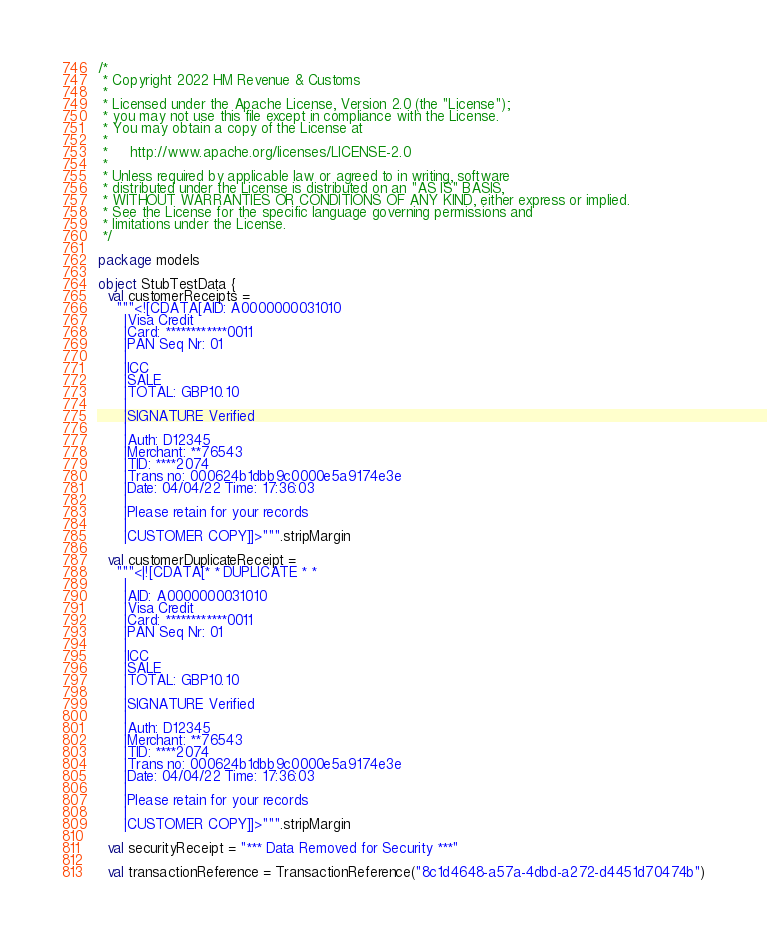<code> <loc_0><loc_0><loc_500><loc_500><_Scala_>/*
 * Copyright 2022 HM Revenue & Customs
 *
 * Licensed under the Apache License, Version 2.0 (the "License");
 * you may not use this file except in compliance with the License.
 * You may obtain a copy of the License at
 *
 *     http://www.apache.org/licenses/LICENSE-2.0
 *
 * Unless required by applicable law or agreed to in writing, software
 * distributed under the License is distributed on an "AS IS" BASIS,
 * WITHOUT WARRANTIES OR CONDITIONS OF ANY KIND, either express or implied.
 * See the License for the specific language governing permissions and
 * limitations under the License.
 */

package models

object StubTestData {
  val customerReceipts =
    """<![CDATA[AID: A0000000031010
      |Visa Credit
      |Card: ************0011
      |PAN Seq Nr: 01
      |
      |ICC
      |SALE
      |TOTAL: GBP10.10
      |
      |SIGNATURE Verified
      |
      |Auth: D12345
      |Merchant: **76543
      |TID: ****2074
      |Trans no: 000624b1dbb9c0000e5a9174e3e
      |Date: 04/04/22 Time: 17:36:03
      |
      |Please retain for your records
      |
      |CUSTOMER COPY]]>""".stripMargin

  val customerDuplicateReceipt =
    """<|![CDATA[* * DUPLICATE * *
      |
      |AID: A0000000031010
      |Visa Credit
      |Card: ************0011
      |PAN Seq Nr: 01
      |
      |ICC
      |SALE
      |TOTAL: GBP10.10
      |
      |SIGNATURE Verified
      |
      |Auth: D12345
      |Merchant: **76543
      |TID: ****2074
      |Trans no: 000624b1dbb9c0000e5a9174e3e
      |Date: 04/04/22 Time: 17:36:03
      |
      |Please retain for your records
      |
      |CUSTOMER COPY]]>""".stripMargin

  val securityReceipt = "*** Data Removed for Security ***"

  val transactionReference = TransactionReference("8c1d4648-a57a-4dbd-a272-d4451d70474b")
</code> 